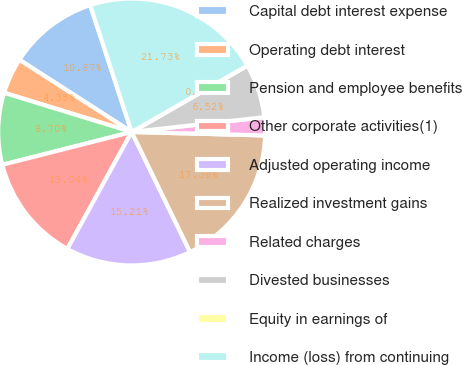Convert chart. <chart><loc_0><loc_0><loc_500><loc_500><pie_chart><fcel>Capital debt interest expense<fcel>Operating debt interest<fcel>Pension and employee benefits<fcel>Other corporate activities(1)<fcel>Adjusted operating income<fcel>Realized investment gains<fcel>Related charges<fcel>Divested businesses<fcel>Equity in earnings of<fcel>Income (loss) from continuing<nl><fcel>10.87%<fcel>4.35%<fcel>8.7%<fcel>13.04%<fcel>15.21%<fcel>17.38%<fcel>2.18%<fcel>6.52%<fcel>0.01%<fcel>21.73%<nl></chart> 